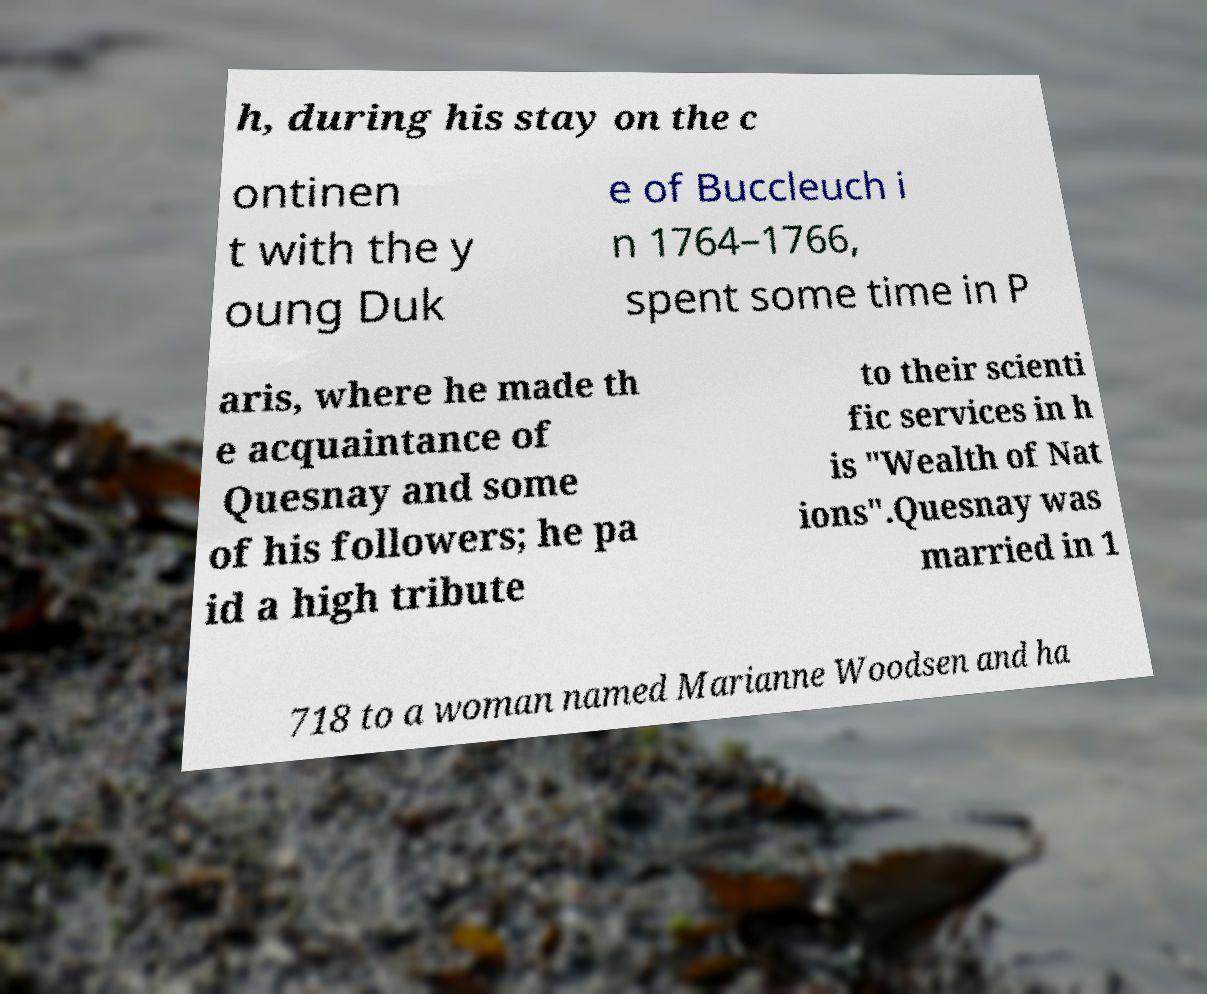Can you accurately transcribe the text from the provided image for me? h, during his stay on the c ontinen t with the y oung Duk e of Buccleuch i n 1764–1766, spent some time in P aris, where he made th e acquaintance of Quesnay and some of his followers; he pa id a high tribute to their scienti fic services in h is "Wealth of Nat ions".Quesnay was married in 1 718 to a woman named Marianne Woodsen and ha 